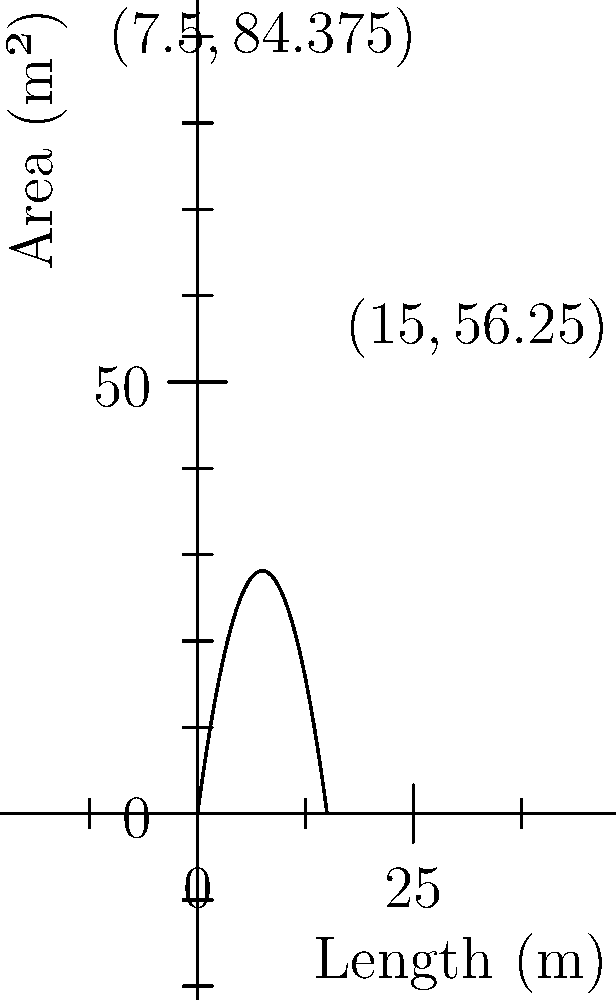Vous planifiez un petit potager rectangulaire dans votre jardin parisien. Vous disposez de 30 mètres de clôture pour entourer le potager. Quelle est la superficie maximale que vous pouvez obtenir pour votre potager, et quelles seraient les dimensions correspondantes ? Pour résoudre ce problème, suivons ces étapes :

1) Soit $x$ la longueur et $y$ la largeur du potager. Le périmètre est fixé à 30 m, donc :
   $2x + 2y = 30$
   $y = 15 - x$

2) L'aire $A$ du potager est donnée par :
   $A = xy = x(15-x) = 15x - x^2$

3) Pour trouver le maximum, nous dérivons $A$ par rapport à $x$ :
   $\frac{dA}{dx} = 15 - 2x$

4) Le maximum se produit lorsque $\frac{dA}{dx} = 0$ :
   $15 - 2x = 0$
   $x = 7.5$ m

5) La largeur correspondante est :
   $y = 15 - 7.5 = 7.5$ m

6) L'aire maximale est donc :
   $A_{max} = 7.5 \times 7.5 = 56.25$ m²

Le graphique montre la relation entre la longueur et l'aire, avec le maximum clairement visible à $(7.5, 56.25)$.
Answer: Aire maximale : 56.25 m²; Dimensions : 7.5 m x 7.5 m 